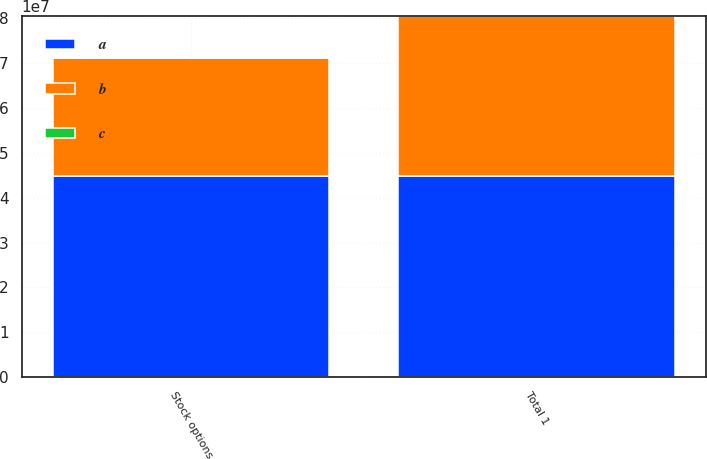Convert chart. <chart><loc_0><loc_0><loc_500><loc_500><stacked_bar_chart><ecel><fcel>Stock options<fcel>Total 1<nl><fcel>b<fcel>2.63364e+07<fcel>3.56861e+07<nl><fcel>c<fcel>63.93<fcel>63.93<nl><fcel>a<fcel>4.48379e+07<fcel>4.48379e+07<nl></chart> 